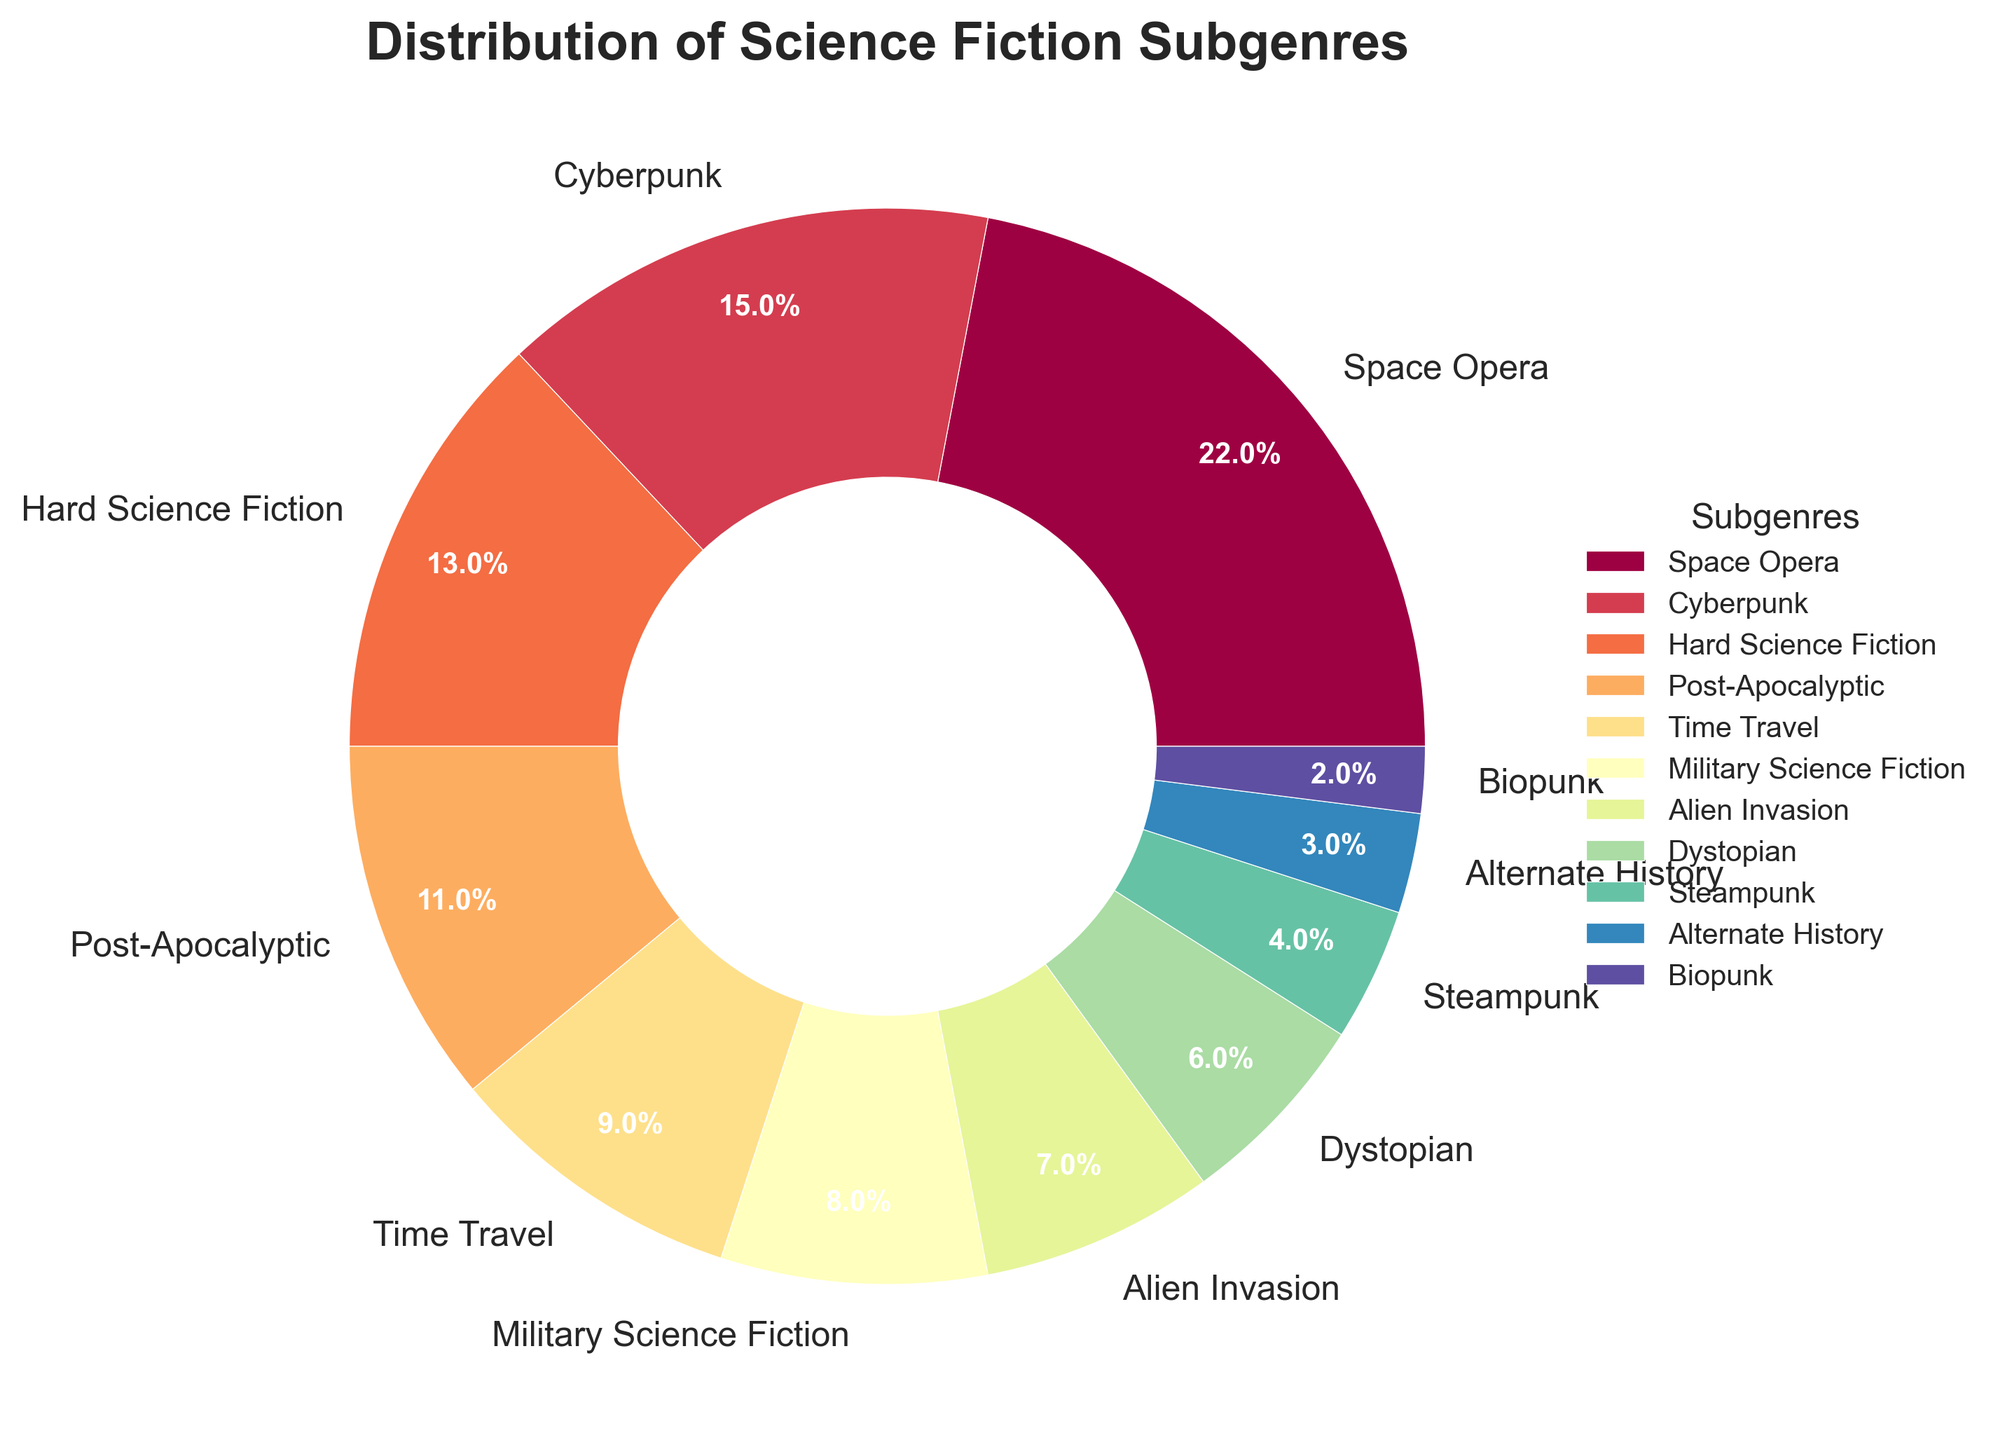Which subgenre has the largest percentage? The subgenre with the largest percentage can be identified by finding the largest wedge in the pie chart. The Space Opera subgenre has the largest wedge, indicating it has the highest percentage.
Answer: Space Opera Which subgenre has the smallest representation in the library's collection? The subgenre with the smallest representation is the one with the smallest wedge in the pie chart. The Biopunk subgenre has the smallest wedge, indicating it has the smallest percentage.
Answer: Biopunk What is the total percentage of Space Opera and Cyberpunk combined? To find the total percentage, sum the individual percentages of Space Opera and Cyberpunk. Space Opera is 22% and Cyberpunk is 15%, so 22% + 15% = 37%.
Answer: 37% Is the percentage of Hard Science Fiction greater than Dystopian? To determine this, compare the wedges for Hard Science Fiction and Dystopian. Hard Science Fiction is 13%, while Dystopian is 6%, making Hard Science Fiction greater.
Answer: Yes Which subgenre has a slightly smaller percentage than Time Travel? By comparing the wedges adjacent to Time Travel's wedge, the one with a slightly smaller percentage is Military Science Fiction, which is 8% compared to Time Travel's 9%.
Answer: Military Science Fiction How many subgenres represent less than 10% of the collection? Count the number of wedges in the pie chart that represent less than 10%. There are six subgenres with percentages less than 10%: Time Travel (9%), Military Science Fiction (8%), Alien Invasion (7%), Dystopian (6%), Steampunk (4%), and Biopunk (2%).
Answer: 6 Is the sum of Post-Apocalyptic and Alien Invasion percentage less than that of Space Opera? First, add the percentages of Post-Apocalyptic and Alien Invasion: 11% + 7% = 18%. Compare this with Space Opera's 22%. Since 18% is less than 22%, the sum is indeed less.
Answer: Yes By how much does the percentage of Cyberpunk exceed that of Steampunk? Subtract the percentage of Steampunk from Cyberpunk. Cyberpunk is 15% and Steampunk is 4%, so the difference is 15% - 4% = 11%.
Answer: 11% What is the combined percentage of the three smallest subgenres? Identify the three smallest subgenres: Biopunk (2%), Alternate History (3%), and Steampunk (4%). Sum these percentages: 2% + 3% + 4% = 9%.
Answer: 9% What is the percentage difference between Space Opera and Military Science Fiction? Subtract the Military Science Fiction percentage from the Space Opera percentage. Space Opera is 22%, and Military Science Fiction is 8%, so the difference is 22% - 8% = 14%.
Answer: 14% 